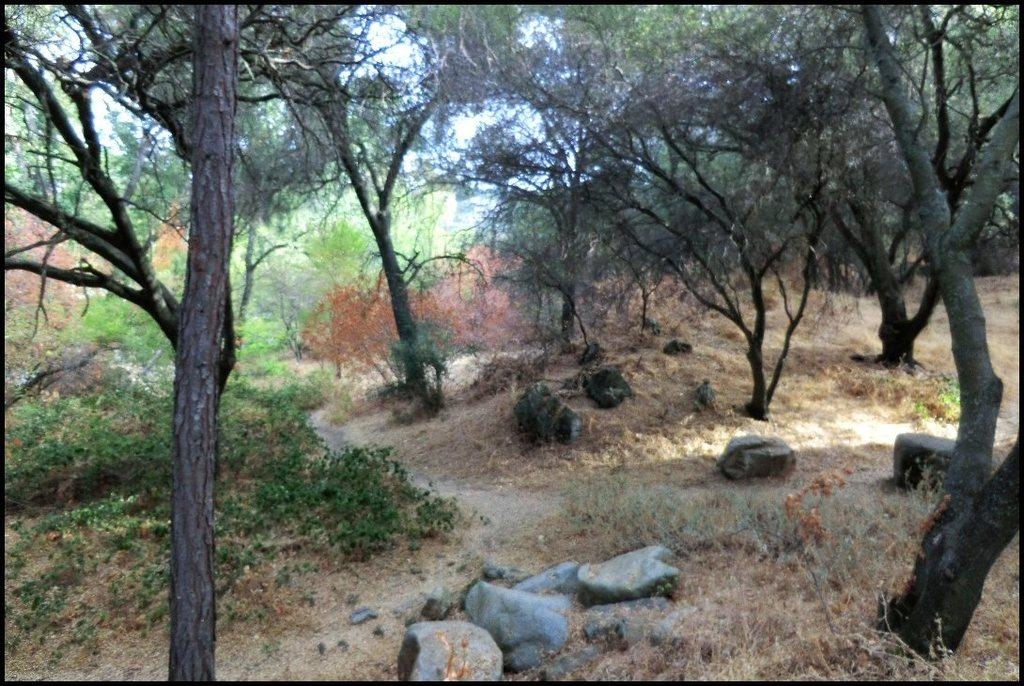What type of natural elements can be seen in the image? There are stones and trees in the image. What is visible at the top of the image? The sky is visible at the top of the image. How many nerves can be seen in the image? There are no nerves visible in the image; it features stones, trees, and the sky. Can you tell me how many cars are present in the image? There are no cars present in the image. 